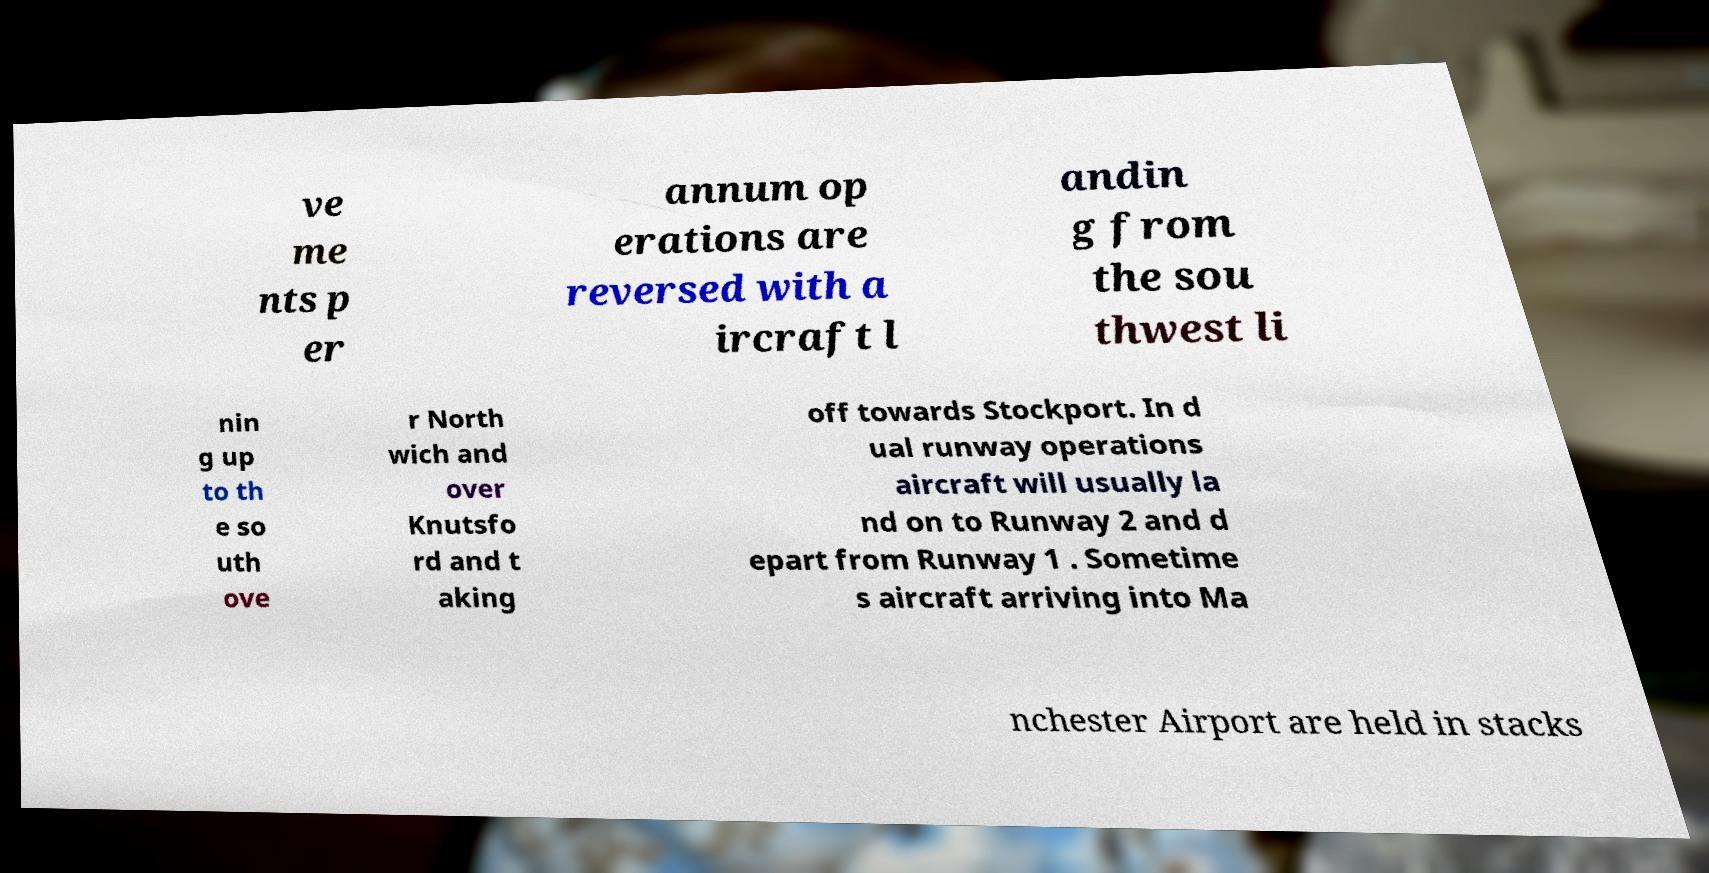What messages or text are displayed in this image? I need them in a readable, typed format. ve me nts p er annum op erations are reversed with a ircraft l andin g from the sou thwest li nin g up to th e so uth ove r North wich and over Knutsfo rd and t aking off towards Stockport. In d ual runway operations aircraft will usually la nd on to Runway 2 and d epart from Runway 1 . Sometime s aircraft arriving into Ma nchester Airport are held in stacks 